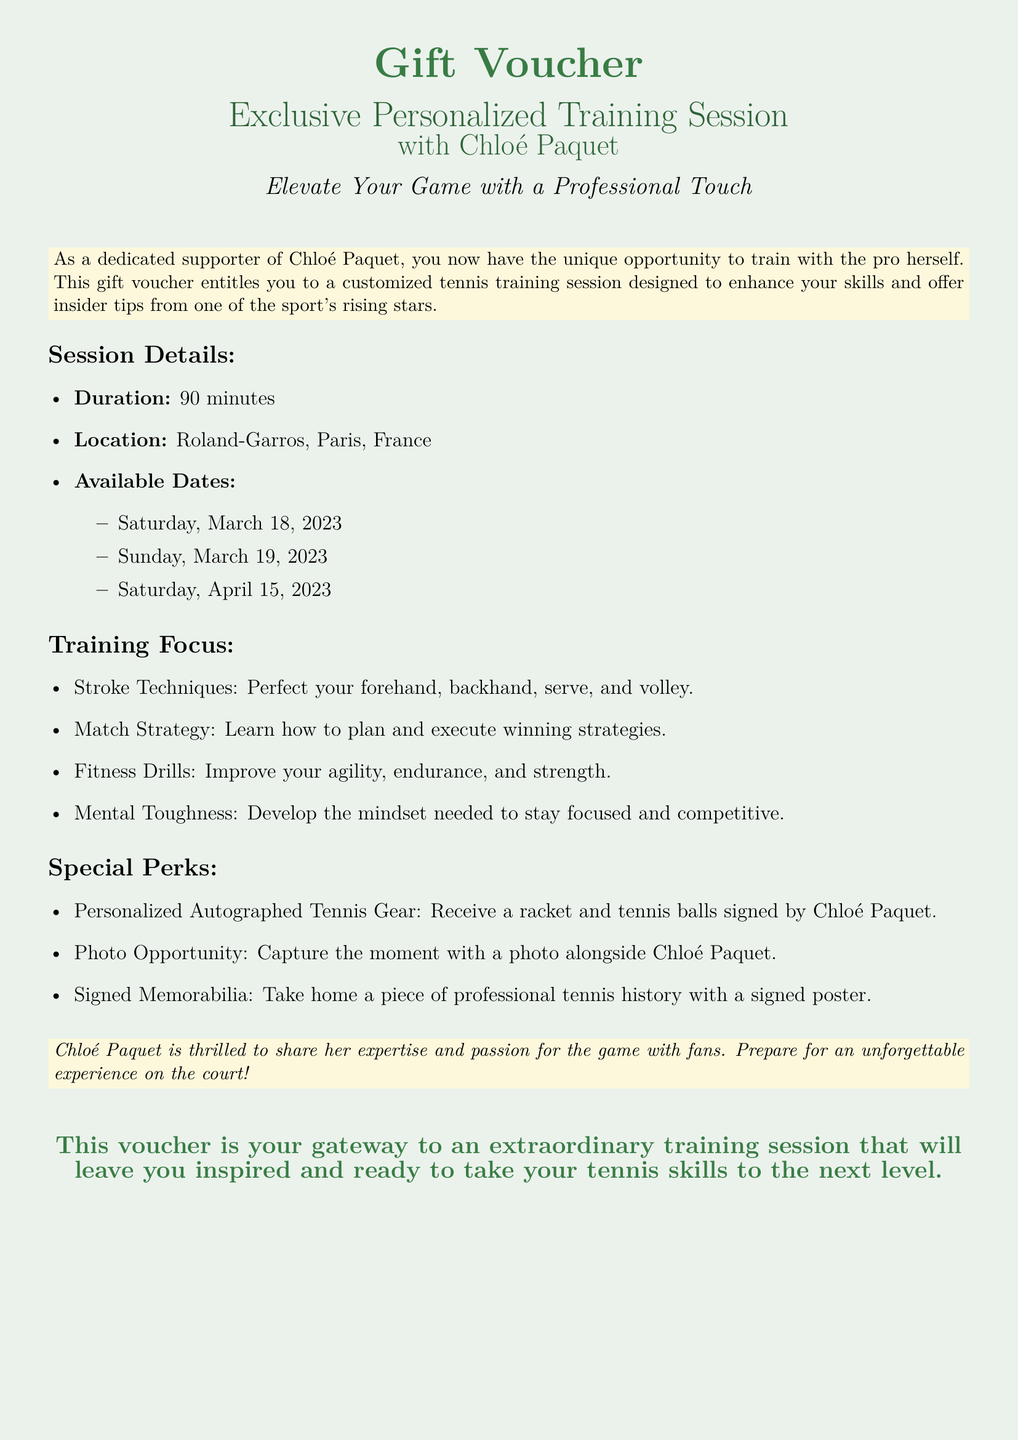What is the duration of the training session? The document specifies the duration of the training session as 90 minutes.
Answer: 90 minutes Where will the training session take place? The location of the training session is mentioned as Roland-Garros, Paris, France.
Answer: Roland-Garros, Paris, France What are the available dates for the training session? The available dates include Saturday, March 18, 2023, and others as listed in the document.
Answer: Saturday, March 18, 2023 What is one focus area of the training? The document lists several focus areas, including stroke techniques, match strategy, and others.
Answer: Stroke Techniques What special perk includes signed items? The document mentions personalized autographed tennis gear among the special perks offered.
Answer: Personalized Autographed Tennis Gear What does Chloé Paquet aim to provide during the training? The document highlights that Chloé Paquet aims to share her expertise and passion for the game.
Answer: Expertise and passion How long is the voucher valid for? The document does not specify the validity of the voucher, leaving it unclear.
Answer: Not specified What type of document is this? This document is a gift voucher offering a training session.
Answer: Gift Voucher 